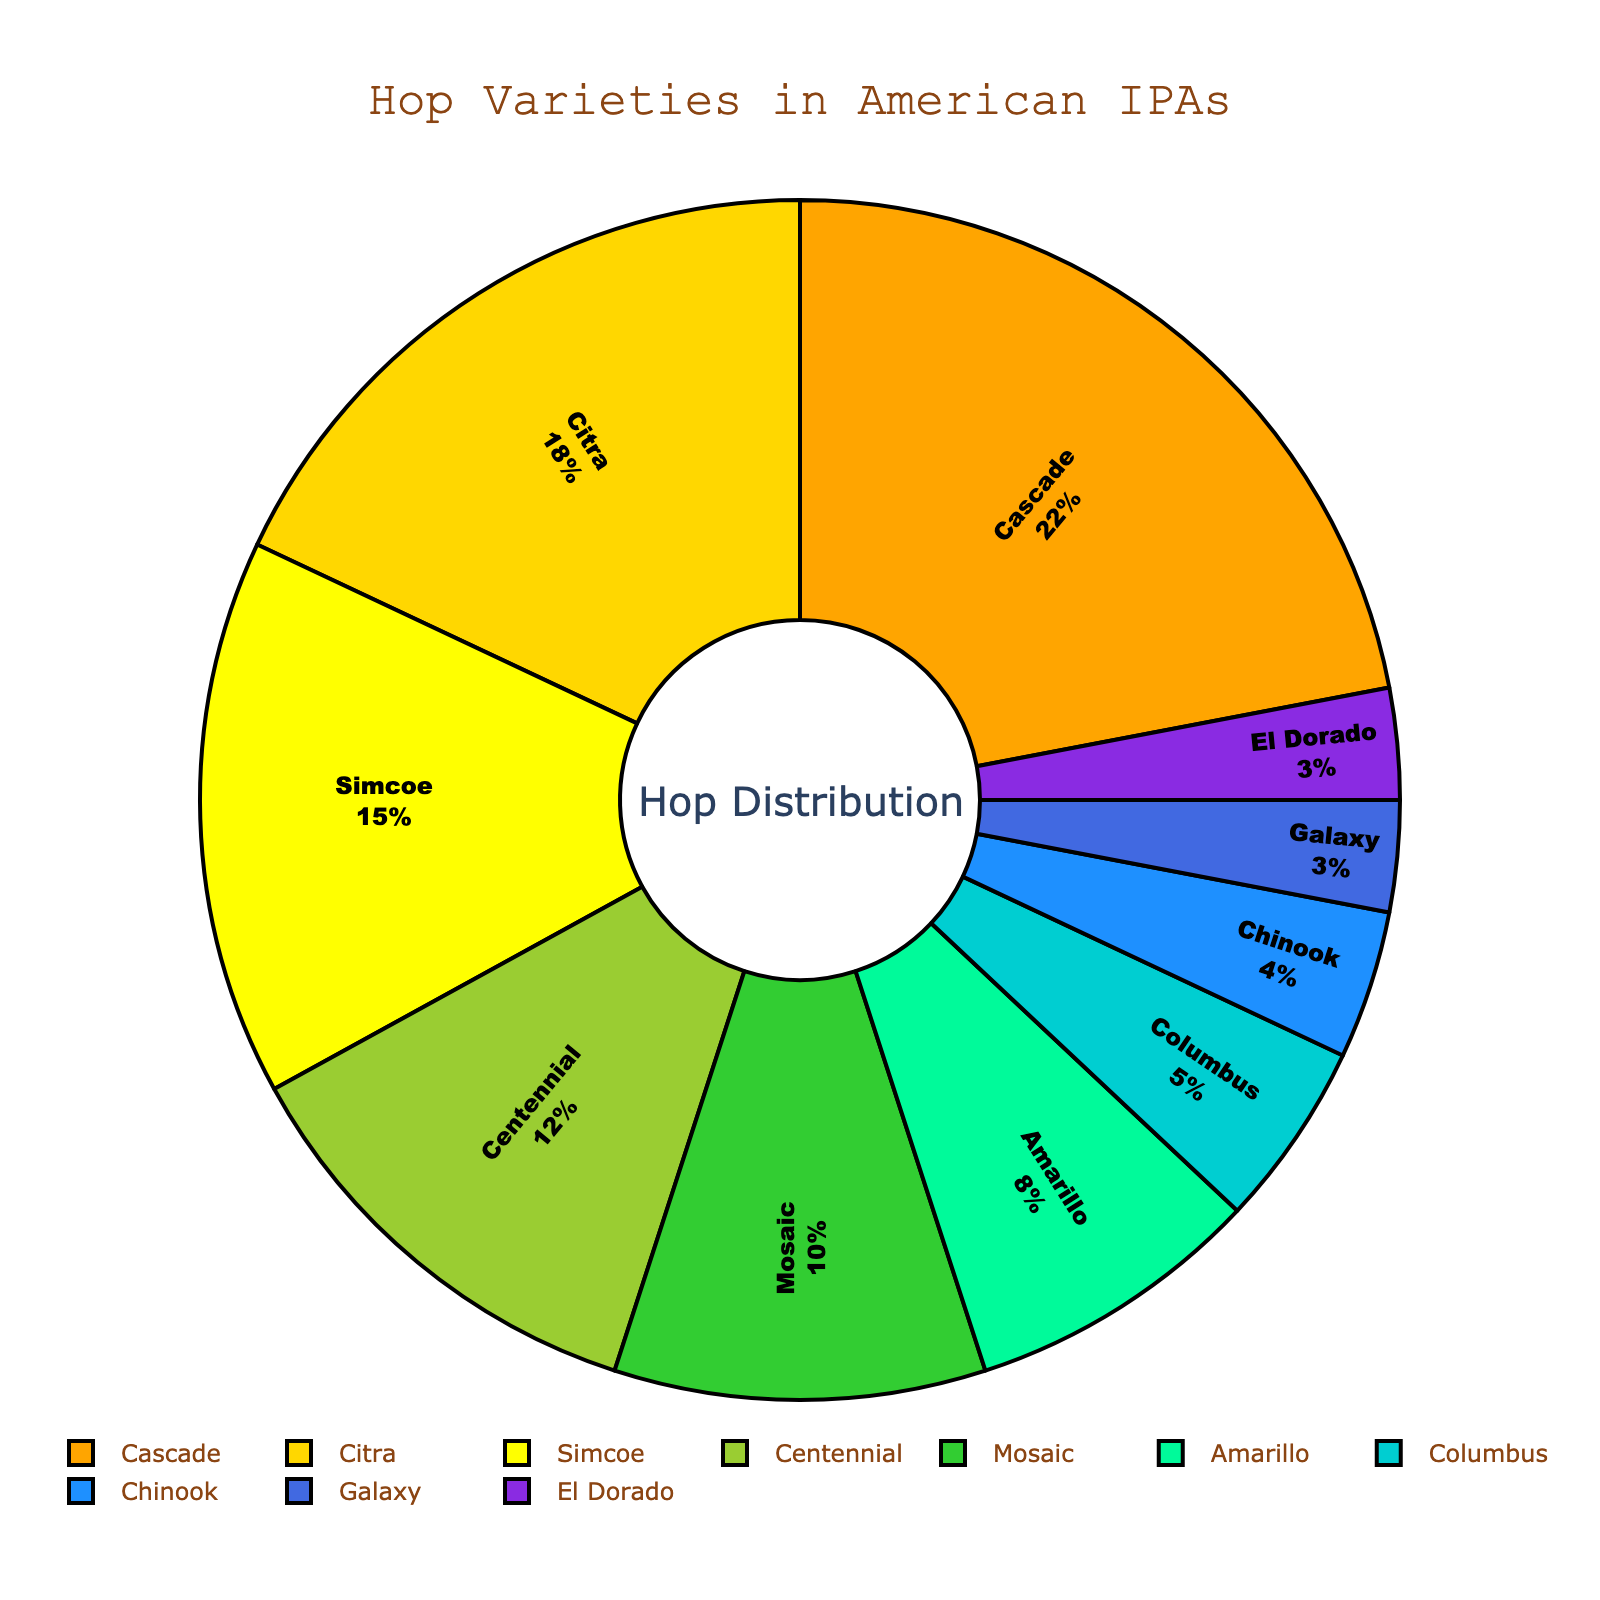What are the top three hop varieties used in American IPAs? The top three hop varieties can be determined by looking at the slices of the pie chart with the largest percentages. They are usually noted with their percentage values inside the slices.
Answer: Cascade, Citra, Simcoe Which hop variety is used more, Mosaic or Centennial? By comparing the percentages of Mosaic and Centennial from the pie chart, we see that Centennial is 12% while Mosaic is 10%. Therefore, Centennial is used more than Mosaic.
Answer: Centennial What is the combined percentage of Citra and Amarillo hops? To find the combined percentage, sum the individual percentages for Citra and Amarillo. From the pie chart, Citra is 18% and Amarillo is 8%, so 18% + 8% = 26%.
Answer: 26% How much more is Cascade used compared to Columbus? From the pie chart, Cascade is at 22% and Columbus at 5%. The difference is calculated as 22% - 5% = 17%.
Answer: 17% Which hop varieties are the least used and what is their total percentage? The least used hop varieties can be identified by looking for the smallest slices in the pie chart, which are Galaxy (3%) and El Dorado (3%). Adding these together, the total is 3% + 3% = 6%.
Answer: Galaxy and El Dorado, 6% Is the percentage of Simcoe hops greater than the combined percentage of Chinook and El Dorado? First, identify the percentages: Simcoe is 15%, Chinook is 4%, and El Dorado is 3%. The combined percentage of Chinook and El Dorado is 4% + 3% = 7%. Since 15% is greater than 7%, Simcoe is used more.
Answer: Yes How many hop varieties are used less than 10%? Count the slices in the pie chart that have percentage values less than 10%. These are Columbus (5%), Chinook (4%), Galaxy (3%), and El Dorado (3%), making a total of 4 varieties.
Answer: 4 If you exclude the top three hop varieties, what percentage do the remaining hop varieties make up? First, sum the top three varieties: Cascade (22%), Citra (18%), and Simcoe (15%) which equals 55%. Subtract this from 100%: 100% - 55% = 45%.
Answer: 45% What is the difference between the most and the least used hop varieties? The most used hop variety is Cascade at 22%, and the least used are Galaxy and El Dorado at 3%. The difference is 22% - 3% = 19%.
Answer: 19% What is the average percentage of the following hop varieties: Amarillo, Columbus, and Chinook? First, find the sum of their percentages: Amarillo (8%), Columbus (5%), and Chinook (4%). The sum is 8% + 5% + 4% = 17%. Then, divide by the number of hop varieties (3): 17% / 3 = ~5.67%.
Answer: ~5.67% 